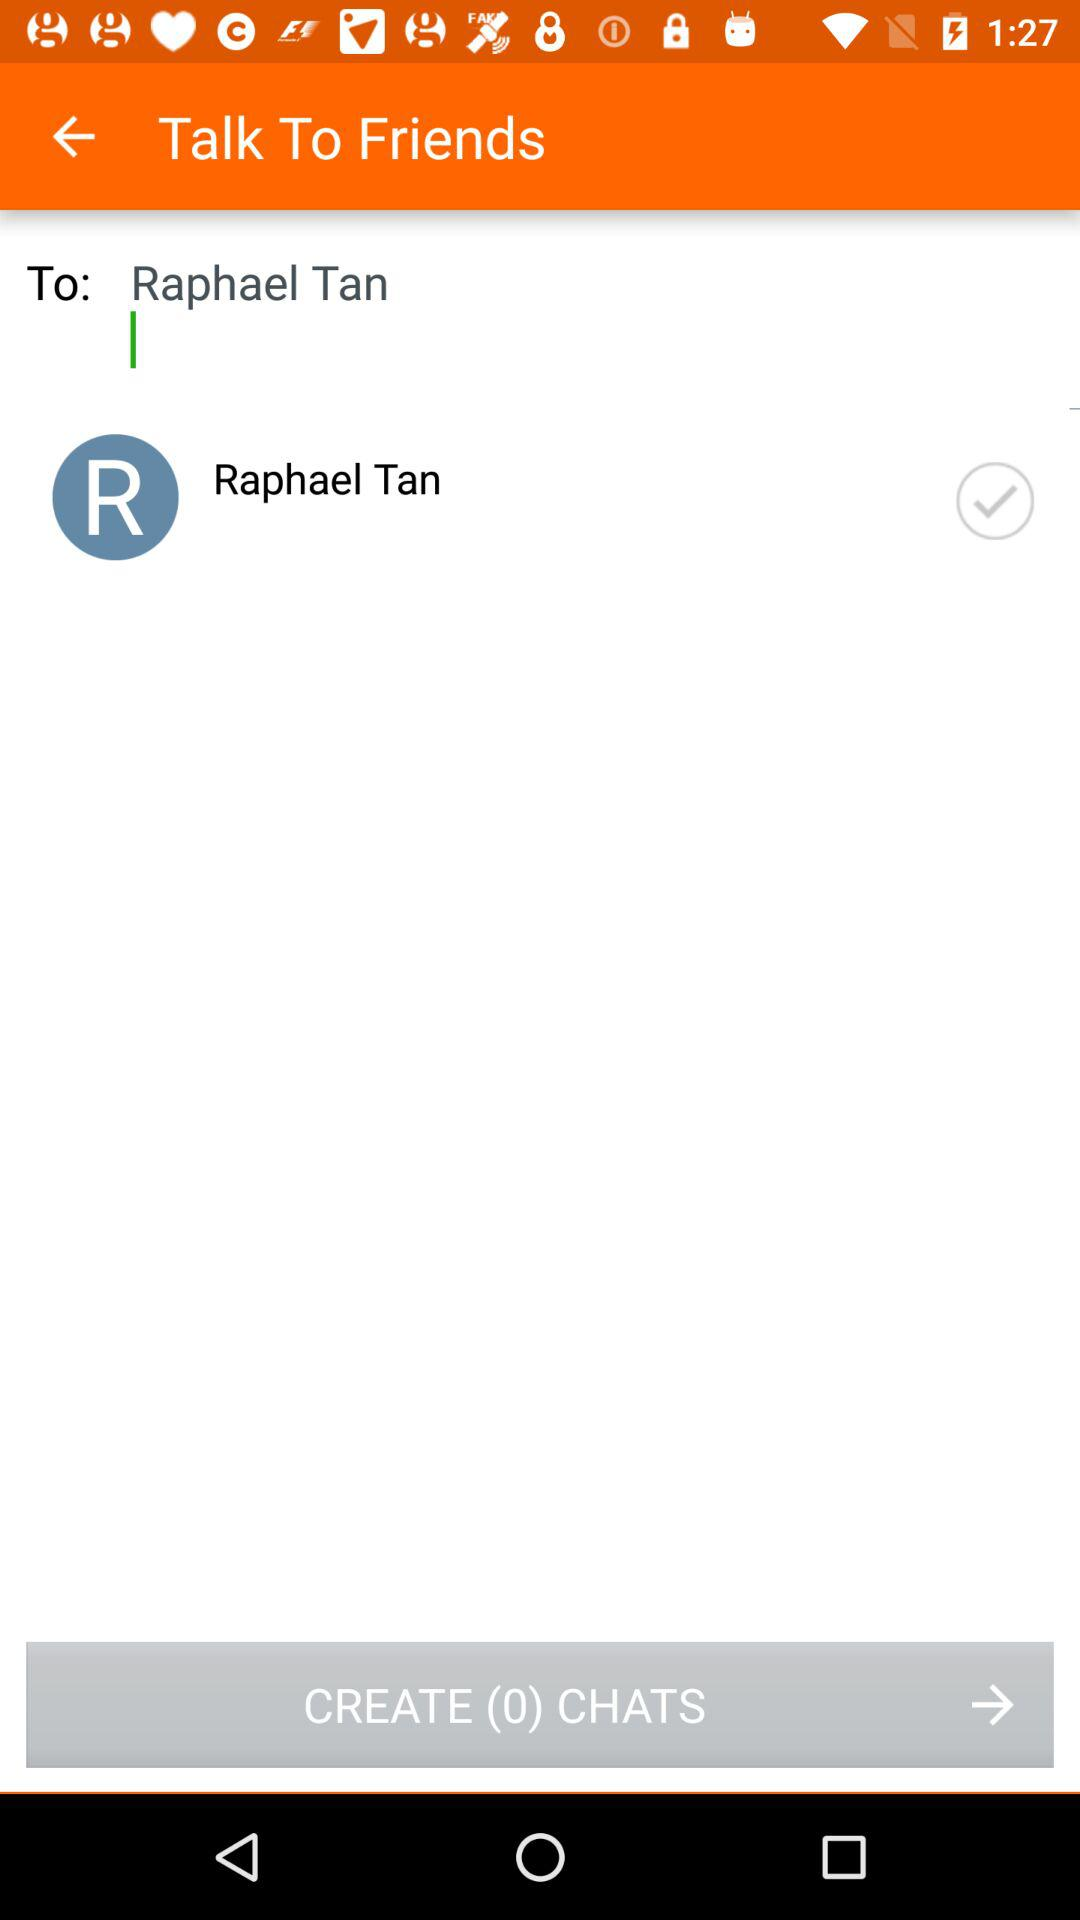How many chats are shown here?
When the provided information is insufficient, respond with <no answer>. <no answer> 